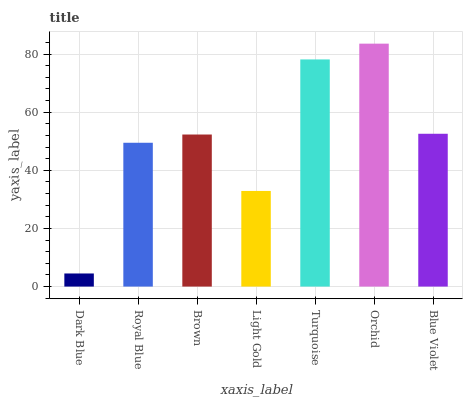Is Dark Blue the minimum?
Answer yes or no. Yes. Is Orchid the maximum?
Answer yes or no. Yes. Is Royal Blue the minimum?
Answer yes or no. No. Is Royal Blue the maximum?
Answer yes or no. No. Is Royal Blue greater than Dark Blue?
Answer yes or no. Yes. Is Dark Blue less than Royal Blue?
Answer yes or no. Yes. Is Dark Blue greater than Royal Blue?
Answer yes or no. No. Is Royal Blue less than Dark Blue?
Answer yes or no. No. Is Brown the high median?
Answer yes or no. Yes. Is Brown the low median?
Answer yes or no. Yes. Is Turquoise the high median?
Answer yes or no. No. Is Orchid the low median?
Answer yes or no. No. 